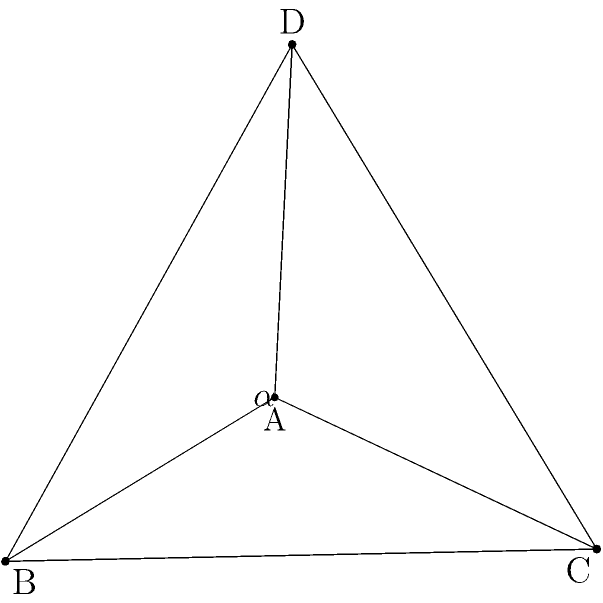In a star-shaped religious symbol, we have a tetrahedron ABCD where ABC forms an equilateral triangle with side length 1, and D is positioned so that all edges connected to D have equal length. If the angle between planes ABD and ACD is denoted as $\alpha$, determine $\cos\alpha$. To find the angle between two planes, we need to calculate the dot product of their normal vectors. Let's approach this step-by-step:

1) First, let's find the coordinates of point D. Since ABC is an equilateral triangle with side length 1, we can set:
   A(0,0,0), B(1,0,0), C(0.5, $\frac{\sqrt{3}}{2}$, 0)
   
   D will be at (0.5, $\frac{\sqrt{3}}{6}$, $\frac{\sqrt{6}}{3}$)

2) Now, let's find the normal vectors of planes ABD and ACD:
   
   For ABD: $\vec{n_1} = \vec{AB} \times \vec{AD} = (1,0,0) \times (0.5, \frac{\sqrt{3}}{6}, \frac{\sqrt{6}}{3}) = (0, -\frac{\sqrt{6}}{3}, \frac{\sqrt{3}}{6})$
   
   For ACD: $\vec{n_2} = \vec{AC} \times \vec{AD} = (0.5, \frac{\sqrt{3}}{2}, 0) \times (0.5, \frac{\sqrt{3}}{6}, \frac{\sqrt{6}}{3}) = (\frac{\sqrt{2}}{2}, -\frac{1}{2\sqrt{2}}, -\frac{\sqrt{3}}{2})$

3) The angle between these planes is given by:

   $\cos\alpha = \frac{\vec{n_1} \cdot \vec{n_2}}{|\vec{n_1}||\vec{n_2}|}$

4) Calculate the dot product:
   $\vec{n_1} \cdot \vec{n_2} = 0 \cdot \frac{\sqrt{2}}{2} + (-\frac{\sqrt{6}}{3}) \cdot (-\frac{1}{2\sqrt{2}}) + \frac{\sqrt{3}}{6} \cdot (-\frac{\sqrt{3}}{2}) = \frac{\sqrt{3}}{2\sqrt{2}} - \frac{1}{4} = \frac{\sqrt{6}}{4} - \frac{1}{4}$

5) Calculate the magnitudes:
   $|\vec{n_1}| = \sqrt{(\frac{\sqrt{6}}{3})^2 + (\frac{\sqrt{3}}{6})^2} = \frac{\sqrt{3}}{2}$
   $|\vec{n_2}| = \sqrt{(\frac{\sqrt{2}}{2})^2 + (\frac{1}{2\sqrt{2}})^2 + (\frac{\sqrt{3}}{2})^2} = 1$

6) Therefore:
   $\cos\alpha = \frac{\frac{\sqrt{6}}{4} - \frac{1}{4}}{\frac{\sqrt{3}}{2} \cdot 1} = \frac{\sqrt{2}}{3} - \frac{1}{3\sqrt{2}}$
Answer: $\frac{\sqrt{2}}{3} - \frac{1}{3\sqrt{2}}$ 